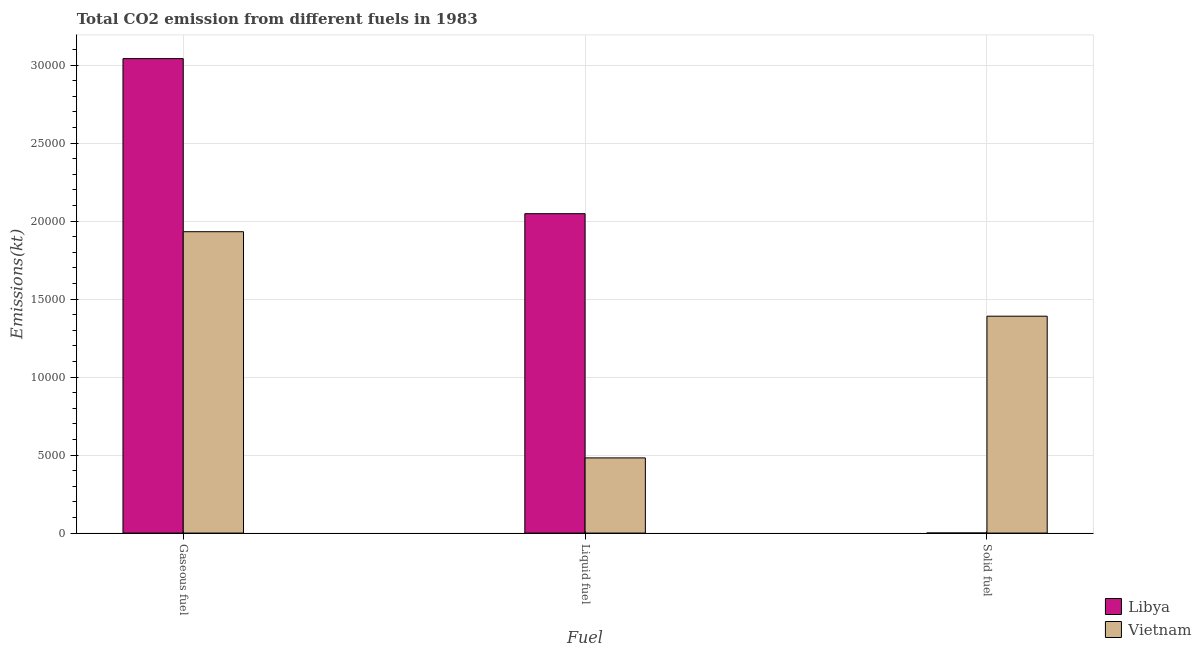How many different coloured bars are there?
Offer a terse response. 2. How many groups of bars are there?
Provide a short and direct response. 3. Are the number of bars per tick equal to the number of legend labels?
Provide a succinct answer. Yes. How many bars are there on the 1st tick from the left?
Offer a very short reply. 2. How many bars are there on the 1st tick from the right?
Keep it short and to the point. 2. What is the label of the 1st group of bars from the left?
Your response must be concise. Gaseous fuel. What is the amount of co2 emissions from gaseous fuel in Vietnam?
Make the answer very short. 1.93e+04. Across all countries, what is the maximum amount of co2 emissions from gaseous fuel?
Your answer should be compact. 3.04e+04. Across all countries, what is the minimum amount of co2 emissions from liquid fuel?
Give a very brief answer. 4818.44. In which country was the amount of co2 emissions from solid fuel maximum?
Offer a terse response. Vietnam. In which country was the amount of co2 emissions from gaseous fuel minimum?
Provide a short and direct response. Vietnam. What is the total amount of co2 emissions from solid fuel in the graph?
Make the answer very short. 1.39e+04. What is the difference between the amount of co2 emissions from solid fuel in Vietnam and that in Libya?
Provide a succinct answer. 1.39e+04. What is the difference between the amount of co2 emissions from gaseous fuel in Libya and the amount of co2 emissions from solid fuel in Vietnam?
Give a very brief answer. 1.65e+04. What is the average amount of co2 emissions from liquid fuel per country?
Ensure brevity in your answer.  1.26e+04. What is the difference between the amount of co2 emissions from gaseous fuel and amount of co2 emissions from solid fuel in Libya?
Your answer should be very brief. 3.04e+04. In how many countries, is the amount of co2 emissions from liquid fuel greater than 26000 kt?
Make the answer very short. 0. What is the ratio of the amount of co2 emissions from solid fuel in Libya to that in Vietnam?
Make the answer very short. 0. Is the difference between the amount of co2 emissions from solid fuel in Libya and Vietnam greater than the difference between the amount of co2 emissions from gaseous fuel in Libya and Vietnam?
Provide a short and direct response. No. What is the difference between the highest and the second highest amount of co2 emissions from gaseous fuel?
Your response must be concise. 1.11e+04. What is the difference between the highest and the lowest amount of co2 emissions from liquid fuel?
Make the answer very short. 1.57e+04. In how many countries, is the amount of co2 emissions from solid fuel greater than the average amount of co2 emissions from solid fuel taken over all countries?
Your answer should be compact. 1. Is the sum of the amount of co2 emissions from solid fuel in Libya and Vietnam greater than the maximum amount of co2 emissions from gaseous fuel across all countries?
Make the answer very short. No. What does the 1st bar from the left in Gaseous fuel represents?
Make the answer very short. Libya. What does the 1st bar from the right in Solid fuel represents?
Give a very brief answer. Vietnam. Is it the case that in every country, the sum of the amount of co2 emissions from gaseous fuel and amount of co2 emissions from liquid fuel is greater than the amount of co2 emissions from solid fuel?
Provide a succinct answer. Yes. Are all the bars in the graph horizontal?
Offer a very short reply. No. Are the values on the major ticks of Y-axis written in scientific E-notation?
Provide a succinct answer. No. Does the graph contain any zero values?
Offer a terse response. No. Does the graph contain grids?
Your response must be concise. Yes. How are the legend labels stacked?
Your answer should be compact. Vertical. What is the title of the graph?
Provide a short and direct response. Total CO2 emission from different fuels in 1983. Does "Northern Mariana Islands" appear as one of the legend labels in the graph?
Your response must be concise. No. What is the label or title of the X-axis?
Ensure brevity in your answer.  Fuel. What is the label or title of the Y-axis?
Keep it short and to the point. Emissions(kt). What is the Emissions(kt) of Libya in Gaseous fuel?
Provide a short and direct response. 3.04e+04. What is the Emissions(kt) in Vietnam in Gaseous fuel?
Your response must be concise. 1.93e+04. What is the Emissions(kt) in Libya in Liquid fuel?
Give a very brief answer. 2.05e+04. What is the Emissions(kt) of Vietnam in Liquid fuel?
Keep it short and to the point. 4818.44. What is the Emissions(kt) of Libya in Solid fuel?
Offer a very short reply. 3.67. What is the Emissions(kt) of Vietnam in Solid fuel?
Offer a terse response. 1.39e+04. Across all Fuel, what is the maximum Emissions(kt) of Libya?
Give a very brief answer. 3.04e+04. Across all Fuel, what is the maximum Emissions(kt) of Vietnam?
Provide a succinct answer. 1.93e+04. Across all Fuel, what is the minimum Emissions(kt) in Libya?
Ensure brevity in your answer.  3.67. Across all Fuel, what is the minimum Emissions(kt) in Vietnam?
Provide a short and direct response. 4818.44. What is the total Emissions(kt) of Libya in the graph?
Offer a very short reply. 5.09e+04. What is the total Emissions(kt) of Vietnam in the graph?
Offer a terse response. 3.80e+04. What is the difference between the Emissions(kt) in Libya in Gaseous fuel and that in Liquid fuel?
Provide a short and direct response. 9941.24. What is the difference between the Emissions(kt) of Vietnam in Gaseous fuel and that in Liquid fuel?
Make the answer very short. 1.45e+04. What is the difference between the Emissions(kt) of Libya in Gaseous fuel and that in Solid fuel?
Offer a very short reply. 3.04e+04. What is the difference between the Emissions(kt) in Vietnam in Gaseous fuel and that in Solid fuel?
Provide a short and direct response. 5416.16. What is the difference between the Emissions(kt) of Libya in Liquid fuel and that in Solid fuel?
Give a very brief answer. 2.05e+04. What is the difference between the Emissions(kt) in Vietnam in Liquid fuel and that in Solid fuel?
Make the answer very short. -9083.16. What is the difference between the Emissions(kt) in Libya in Gaseous fuel and the Emissions(kt) in Vietnam in Liquid fuel?
Keep it short and to the point. 2.56e+04. What is the difference between the Emissions(kt) in Libya in Gaseous fuel and the Emissions(kt) in Vietnam in Solid fuel?
Give a very brief answer. 1.65e+04. What is the difference between the Emissions(kt) in Libya in Liquid fuel and the Emissions(kt) in Vietnam in Solid fuel?
Your answer should be very brief. 6571.26. What is the average Emissions(kt) in Libya per Fuel?
Make the answer very short. 1.70e+04. What is the average Emissions(kt) in Vietnam per Fuel?
Your response must be concise. 1.27e+04. What is the difference between the Emissions(kt) in Libya and Emissions(kt) in Vietnam in Gaseous fuel?
Give a very brief answer. 1.11e+04. What is the difference between the Emissions(kt) of Libya and Emissions(kt) of Vietnam in Liquid fuel?
Give a very brief answer. 1.57e+04. What is the difference between the Emissions(kt) in Libya and Emissions(kt) in Vietnam in Solid fuel?
Offer a very short reply. -1.39e+04. What is the ratio of the Emissions(kt) of Libya in Gaseous fuel to that in Liquid fuel?
Make the answer very short. 1.49. What is the ratio of the Emissions(kt) of Vietnam in Gaseous fuel to that in Liquid fuel?
Ensure brevity in your answer.  4.01. What is the ratio of the Emissions(kt) of Libya in Gaseous fuel to that in Solid fuel?
Offer a terse response. 8294. What is the ratio of the Emissions(kt) of Vietnam in Gaseous fuel to that in Solid fuel?
Provide a succinct answer. 1.39. What is the ratio of the Emissions(kt) in Libya in Liquid fuel to that in Solid fuel?
Give a very brief answer. 5583. What is the ratio of the Emissions(kt) of Vietnam in Liquid fuel to that in Solid fuel?
Ensure brevity in your answer.  0.35. What is the difference between the highest and the second highest Emissions(kt) in Libya?
Provide a succinct answer. 9941.24. What is the difference between the highest and the second highest Emissions(kt) in Vietnam?
Ensure brevity in your answer.  5416.16. What is the difference between the highest and the lowest Emissions(kt) in Libya?
Give a very brief answer. 3.04e+04. What is the difference between the highest and the lowest Emissions(kt) of Vietnam?
Offer a terse response. 1.45e+04. 